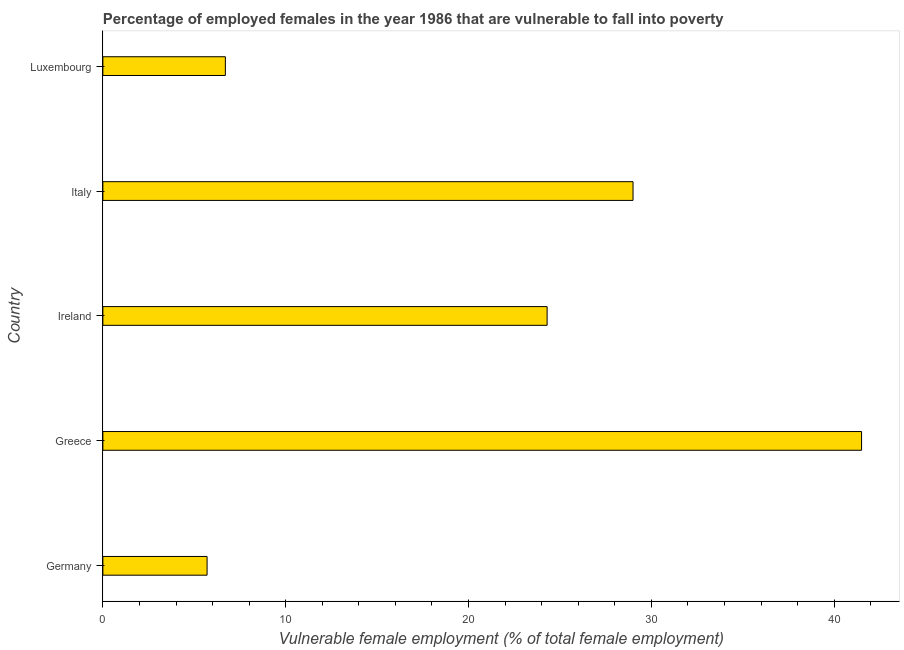What is the title of the graph?
Provide a succinct answer. Percentage of employed females in the year 1986 that are vulnerable to fall into poverty. What is the label or title of the X-axis?
Keep it short and to the point. Vulnerable female employment (% of total female employment). What is the label or title of the Y-axis?
Provide a succinct answer. Country. What is the percentage of employed females who are vulnerable to fall into poverty in Greece?
Your answer should be compact. 41.5. Across all countries, what is the maximum percentage of employed females who are vulnerable to fall into poverty?
Your answer should be compact. 41.5. Across all countries, what is the minimum percentage of employed females who are vulnerable to fall into poverty?
Provide a succinct answer. 5.7. What is the sum of the percentage of employed females who are vulnerable to fall into poverty?
Give a very brief answer. 107.2. What is the difference between the percentage of employed females who are vulnerable to fall into poverty in Germany and Greece?
Provide a succinct answer. -35.8. What is the average percentage of employed females who are vulnerable to fall into poverty per country?
Ensure brevity in your answer.  21.44. What is the median percentage of employed females who are vulnerable to fall into poverty?
Offer a very short reply. 24.3. In how many countries, is the percentage of employed females who are vulnerable to fall into poverty greater than 28 %?
Give a very brief answer. 2. What is the ratio of the percentage of employed females who are vulnerable to fall into poverty in Greece to that in Ireland?
Provide a succinct answer. 1.71. What is the difference between the highest and the lowest percentage of employed females who are vulnerable to fall into poverty?
Ensure brevity in your answer.  35.8. In how many countries, is the percentage of employed females who are vulnerable to fall into poverty greater than the average percentage of employed females who are vulnerable to fall into poverty taken over all countries?
Offer a terse response. 3. How many bars are there?
Make the answer very short. 5. What is the difference between two consecutive major ticks on the X-axis?
Keep it short and to the point. 10. What is the Vulnerable female employment (% of total female employment) of Germany?
Ensure brevity in your answer.  5.7. What is the Vulnerable female employment (% of total female employment) in Greece?
Your answer should be very brief. 41.5. What is the Vulnerable female employment (% of total female employment) in Ireland?
Give a very brief answer. 24.3. What is the Vulnerable female employment (% of total female employment) of Luxembourg?
Provide a succinct answer. 6.7. What is the difference between the Vulnerable female employment (% of total female employment) in Germany and Greece?
Give a very brief answer. -35.8. What is the difference between the Vulnerable female employment (% of total female employment) in Germany and Ireland?
Provide a succinct answer. -18.6. What is the difference between the Vulnerable female employment (% of total female employment) in Germany and Italy?
Offer a terse response. -23.3. What is the difference between the Vulnerable female employment (% of total female employment) in Germany and Luxembourg?
Your answer should be compact. -1. What is the difference between the Vulnerable female employment (% of total female employment) in Greece and Luxembourg?
Make the answer very short. 34.8. What is the difference between the Vulnerable female employment (% of total female employment) in Ireland and Luxembourg?
Make the answer very short. 17.6. What is the difference between the Vulnerable female employment (% of total female employment) in Italy and Luxembourg?
Provide a succinct answer. 22.3. What is the ratio of the Vulnerable female employment (% of total female employment) in Germany to that in Greece?
Your response must be concise. 0.14. What is the ratio of the Vulnerable female employment (% of total female employment) in Germany to that in Ireland?
Ensure brevity in your answer.  0.23. What is the ratio of the Vulnerable female employment (% of total female employment) in Germany to that in Italy?
Provide a short and direct response. 0.2. What is the ratio of the Vulnerable female employment (% of total female employment) in Germany to that in Luxembourg?
Make the answer very short. 0.85. What is the ratio of the Vulnerable female employment (% of total female employment) in Greece to that in Ireland?
Give a very brief answer. 1.71. What is the ratio of the Vulnerable female employment (% of total female employment) in Greece to that in Italy?
Provide a succinct answer. 1.43. What is the ratio of the Vulnerable female employment (% of total female employment) in Greece to that in Luxembourg?
Keep it short and to the point. 6.19. What is the ratio of the Vulnerable female employment (% of total female employment) in Ireland to that in Italy?
Offer a very short reply. 0.84. What is the ratio of the Vulnerable female employment (% of total female employment) in Ireland to that in Luxembourg?
Your answer should be compact. 3.63. What is the ratio of the Vulnerable female employment (% of total female employment) in Italy to that in Luxembourg?
Your answer should be compact. 4.33. 